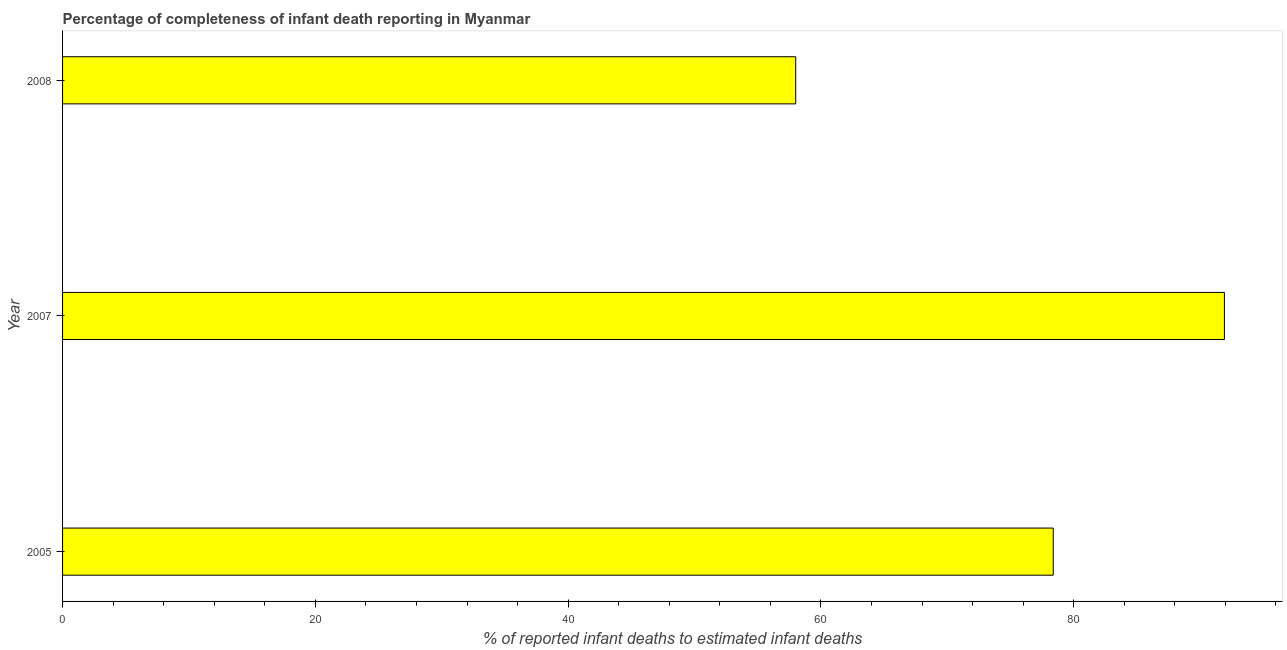Does the graph contain any zero values?
Ensure brevity in your answer.  No. What is the title of the graph?
Provide a succinct answer. Percentage of completeness of infant death reporting in Myanmar. What is the label or title of the X-axis?
Provide a short and direct response. % of reported infant deaths to estimated infant deaths. What is the completeness of infant death reporting in 2008?
Provide a succinct answer. 58.01. Across all years, what is the maximum completeness of infant death reporting?
Your response must be concise. 91.93. Across all years, what is the minimum completeness of infant death reporting?
Provide a succinct answer. 58.01. In which year was the completeness of infant death reporting maximum?
Provide a succinct answer. 2007. What is the sum of the completeness of infant death reporting?
Offer a terse response. 228.32. What is the difference between the completeness of infant death reporting in 2005 and 2007?
Keep it short and to the point. -13.54. What is the average completeness of infant death reporting per year?
Offer a very short reply. 76.11. What is the median completeness of infant death reporting?
Your answer should be very brief. 78.39. What is the ratio of the completeness of infant death reporting in 2005 to that in 2007?
Keep it short and to the point. 0.85. Is the completeness of infant death reporting in 2005 less than that in 2008?
Provide a succinct answer. No. Is the difference between the completeness of infant death reporting in 2005 and 2008 greater than the difference between any two years?
Make the answer very short. No. What is the difference between the highest and the second highest completeness of infant death reporting?
Your answer should be compact. 13.54. Is the sum of the completeness of infant death reporting in 2005 and 2007 greater than the maximum completeness of infant death reporting across all years?
Offer a terse response. Yes. What is the difference between the highest and the lowest completeness of infant death reporting?
Your answer should be very brief. 33.92. How many bars are there?
Give a very brief answer. 3. Are all the bars in the graph horizontal?
Your response must be concise. Yes. How many years are there in the graph?
Give a very brief answer. 3. What is the difference between two consecutive major ticks on the X-axis?
Offer a terse response. 20. Are the values on the major ticks of X-axis written in scientific E-notation?
Offer a very short reply. No. What is the % of reported infant deaths to estimated infant deaths in 2005?
Keep it short and to the point. 78.39. What is the % of reported infant deaths to estimated infant deaths in 2007?
Your response must be concise. 91.93. What is the % of reported infant deaths to estimated infant deaths in 2008?
Your answer should be compact. 58.01. What is the difference between the % of reported infant deaths to estimated infant deaths in 2005 and 2007?
Provide a short and direct response. -13.54. What is the difference between the % of reported infant deaths to estimated infant deaths in 2005 and 2008?
Your answer should be very brief. 20.38. What is the difference between the % of reported infant deaths to estimated infant deaths in 2007 and 2008?
Offer a terse response. 33.92. What is the ratio of the % of reported infant deaths to estimated infant deaths in 2005 to that in 2007?
Keep it short and to the point. 0.85. What is the ratio of the % of reported infant deaths to estimated infant deaths in 2005 to that in 2008?
Give a very brief answer. 1.35. What is the ratio of the % of reported infant deaths to estimated infant deaths in 2007 to that in 2008?
Provide a short and direct response. 1.58. 